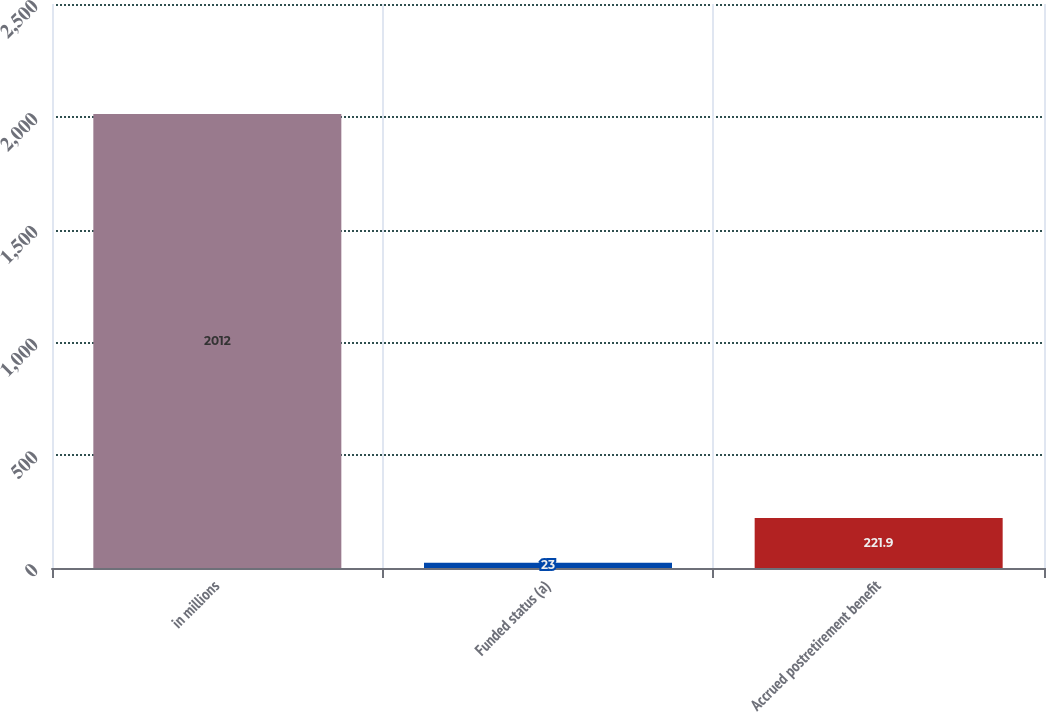Convert chart. <chart><loc_0><loc_0><loc_500><loc_500><bar_chart><fcel>in millions<fcel>Funded status (a)<fcel>Accrued postretirement benefit<nl><fcel>2012<fcel>23<fcel>221.9<nl></chart> 